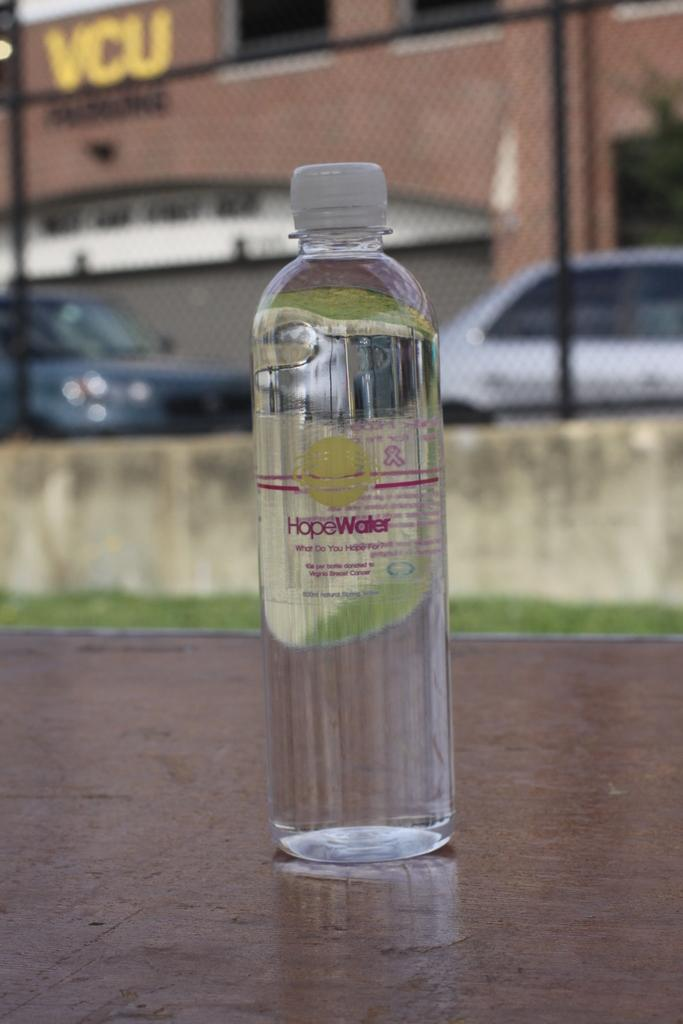What object is the main focus of the image? There is a bottle highlighted in the image. What else can be seen in the image besides the bottle? There are vehicles and a building visible in the image. What type of pear is being used to fuel the vehicles in the image? There is no pear present in the image, and the vehicles are not being fueled by any fruit. 